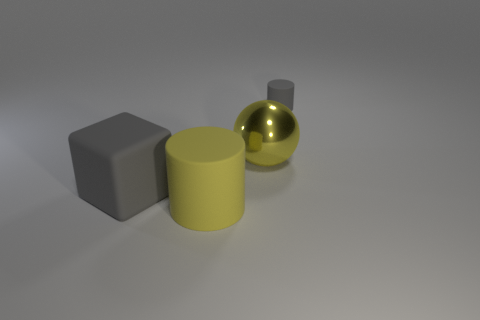Could you describe the lighting in this scene? The lighting in this scene appears to be soft and diffuse, suggesting an overcast or ambient light source. There are gentle shadows under each object, indicating the light source is coming from above. The reflection on the sphere and the slight specular highlights on the cylinder and block also indicate a broad light source. 